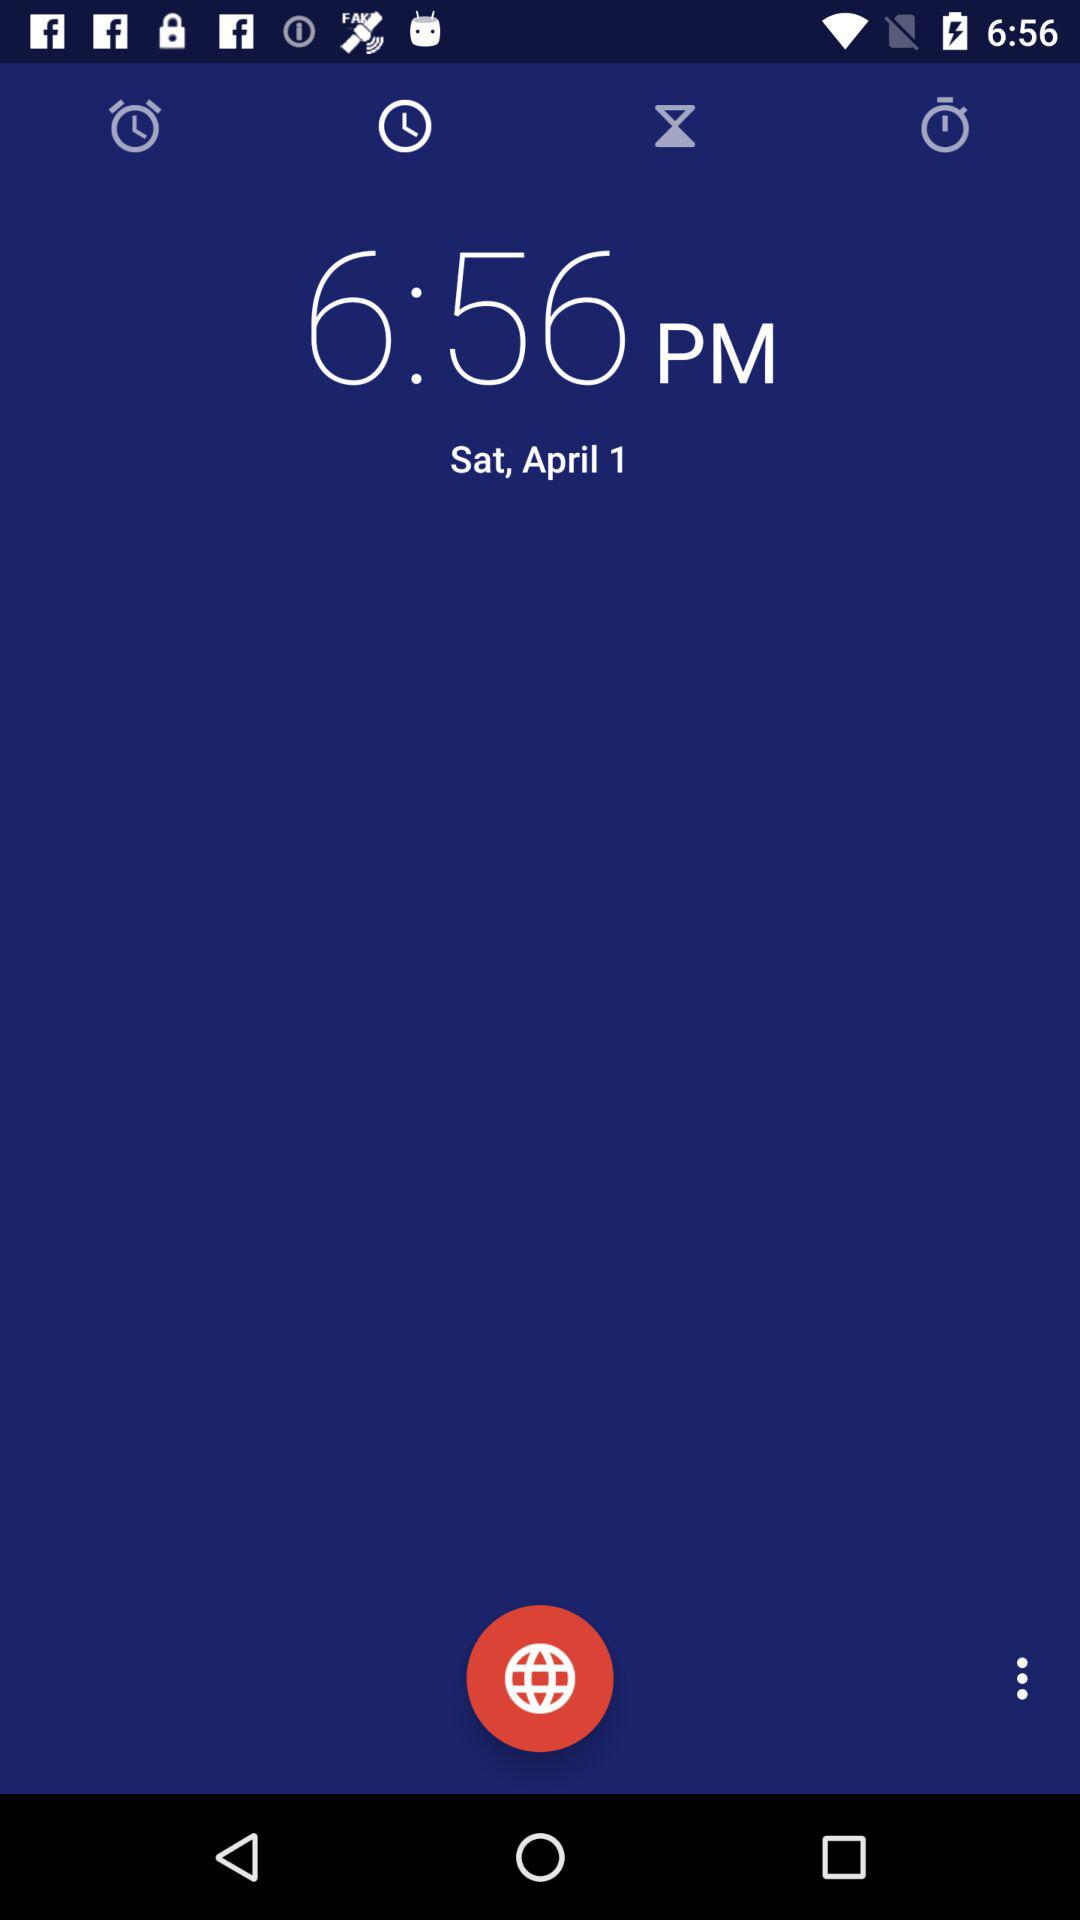What is the mentioned date? The mentioned date is Saturday, April 1. 